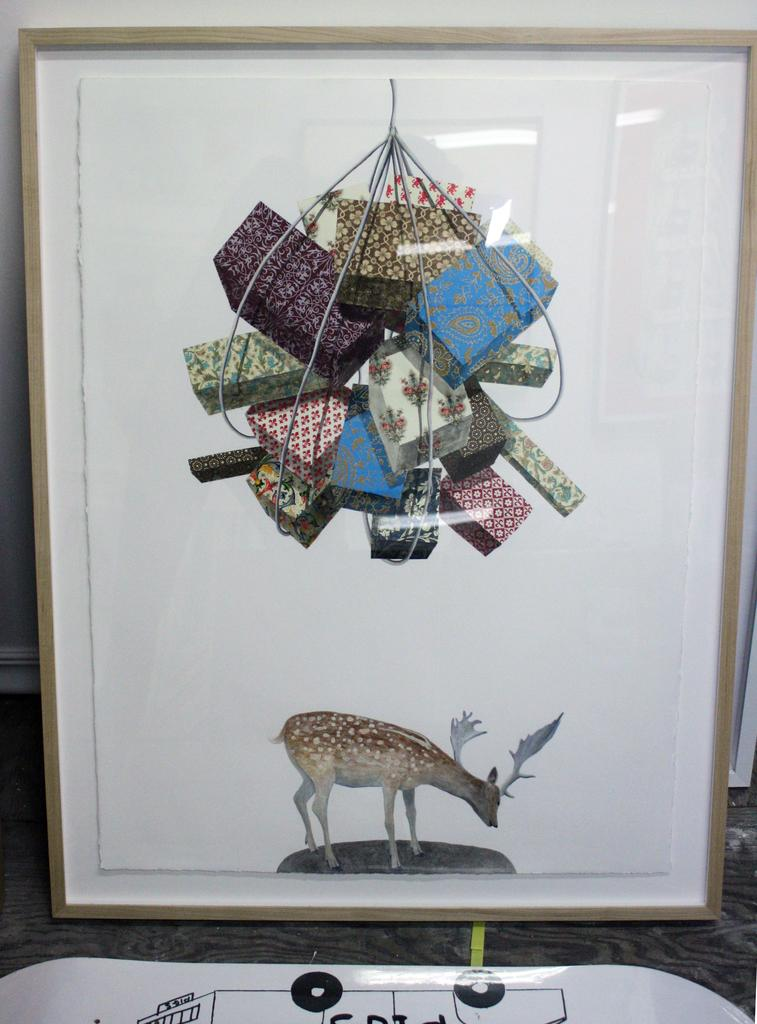What is the main subject of the photo frame in the image? There is a photo frame of a deer in the image. What else can be seen in the image besides the photo frame? There are objects visible in the image. What is behind the photo frame? There is a wall behind the photo frame. Is there anything in front of the photo frame? Yes, there is an object in front of the photo frame. How much money is being lost in the image? There is no mention of money or loss in the image; it features a photo frame of a deer with objects and a wall behind it. 